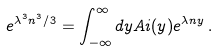Convert formula to latex. <formula><loc_0><loc_0><loc_500><loc_500>e ^ { \lambda ^ { 3 } n ^ { 3 } / 3 } = \int _ { - \infty } ^ { \infty } d y A i ( y ) e ^ { \lambda n y } \, .</formula> 